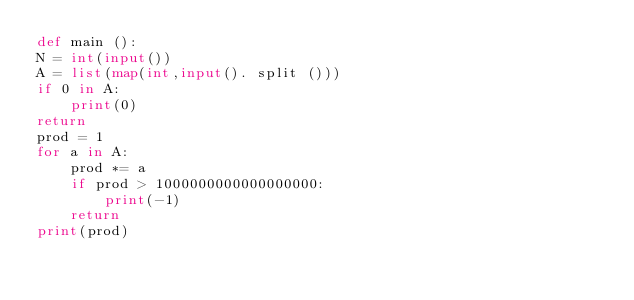<code> <loc_0><loc_0><loc_500><loc_500><_Python_>def main ():
N = int(input())
A = list(map(int,input(). split ()))
if 0 in A:
	print(0)
return
prod = 1
for a in A:
	prod *= a
	if prod > 1000000000000000000:
		print(-1)
	return
print(prod)</code> 